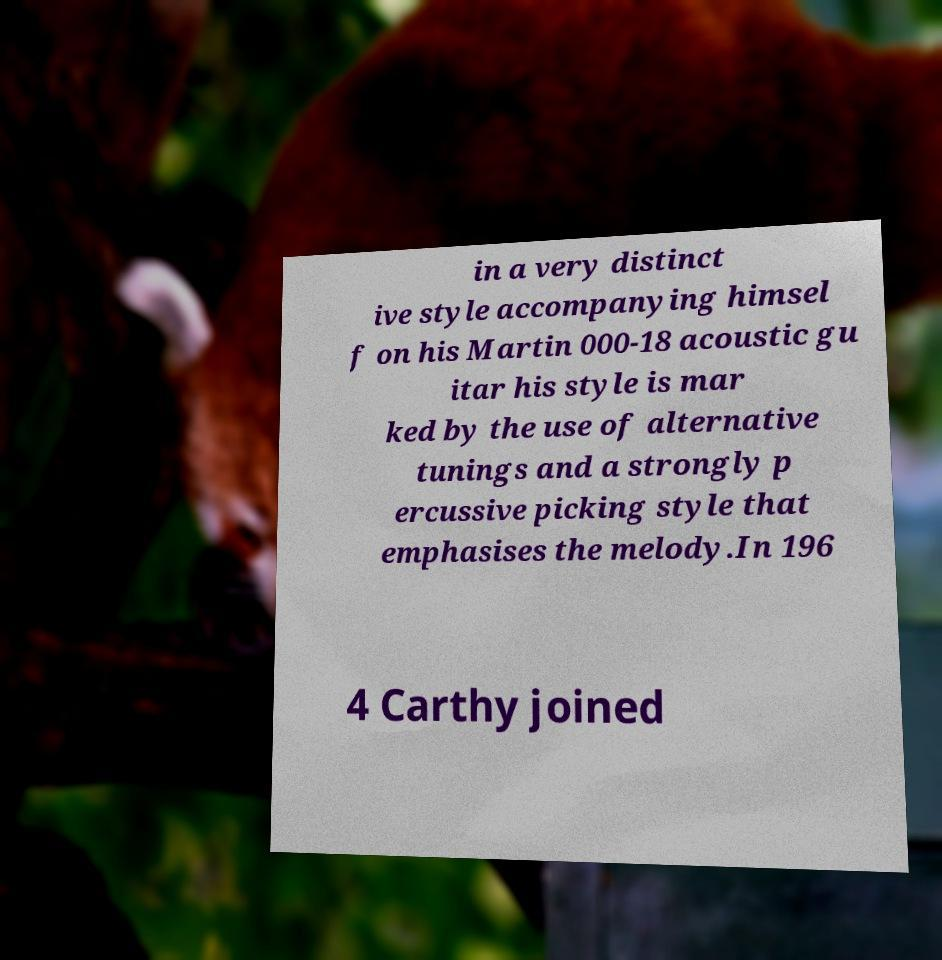I need the written content from this picture converted into text. Can you do that? in a very distinct ive style accompanying himsel f on his Martin 000-18 acoustic gu itar his style is mar ked by the use of alternative tunings and a strongly p ercussive picking style that emphasises the melody.In 196 4 Carthy joined 